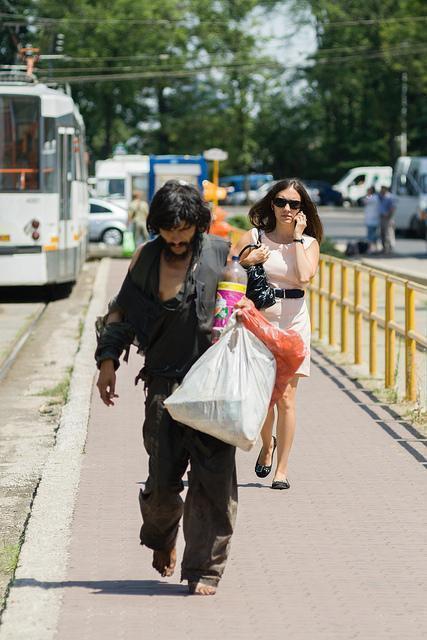What type of phone is the woman using?
Make your selection and explain in format: 'Answer: answer
Rationale: rationale.'
Options: Landline, rotary, pay, cellular. Answer: cellular.
Rationale: The woman is on the go.  the phone is mobile. 